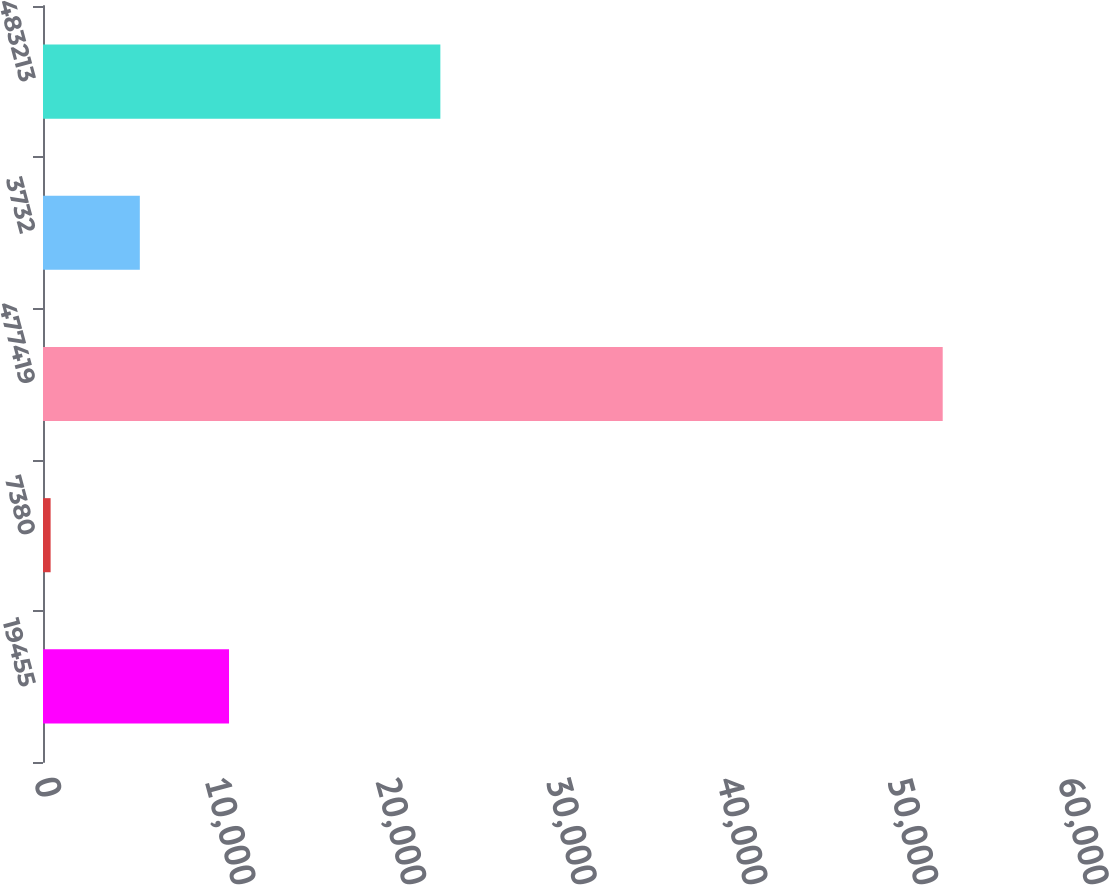Convert chart. <chart><loc_0><loc_0><loc_500><loc_500><bar_chart><fcel>19455<fcel>7380<fcel>477419<fcel>3732<fcel>483213<nl><fcel>10900.2<fcel>446<fcel>52717<fcel>5673.1<fcel>23283<nl></chart> 